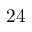<formula> <loc_0><loc_0><loc_500><loc_500>2 4</formula> 